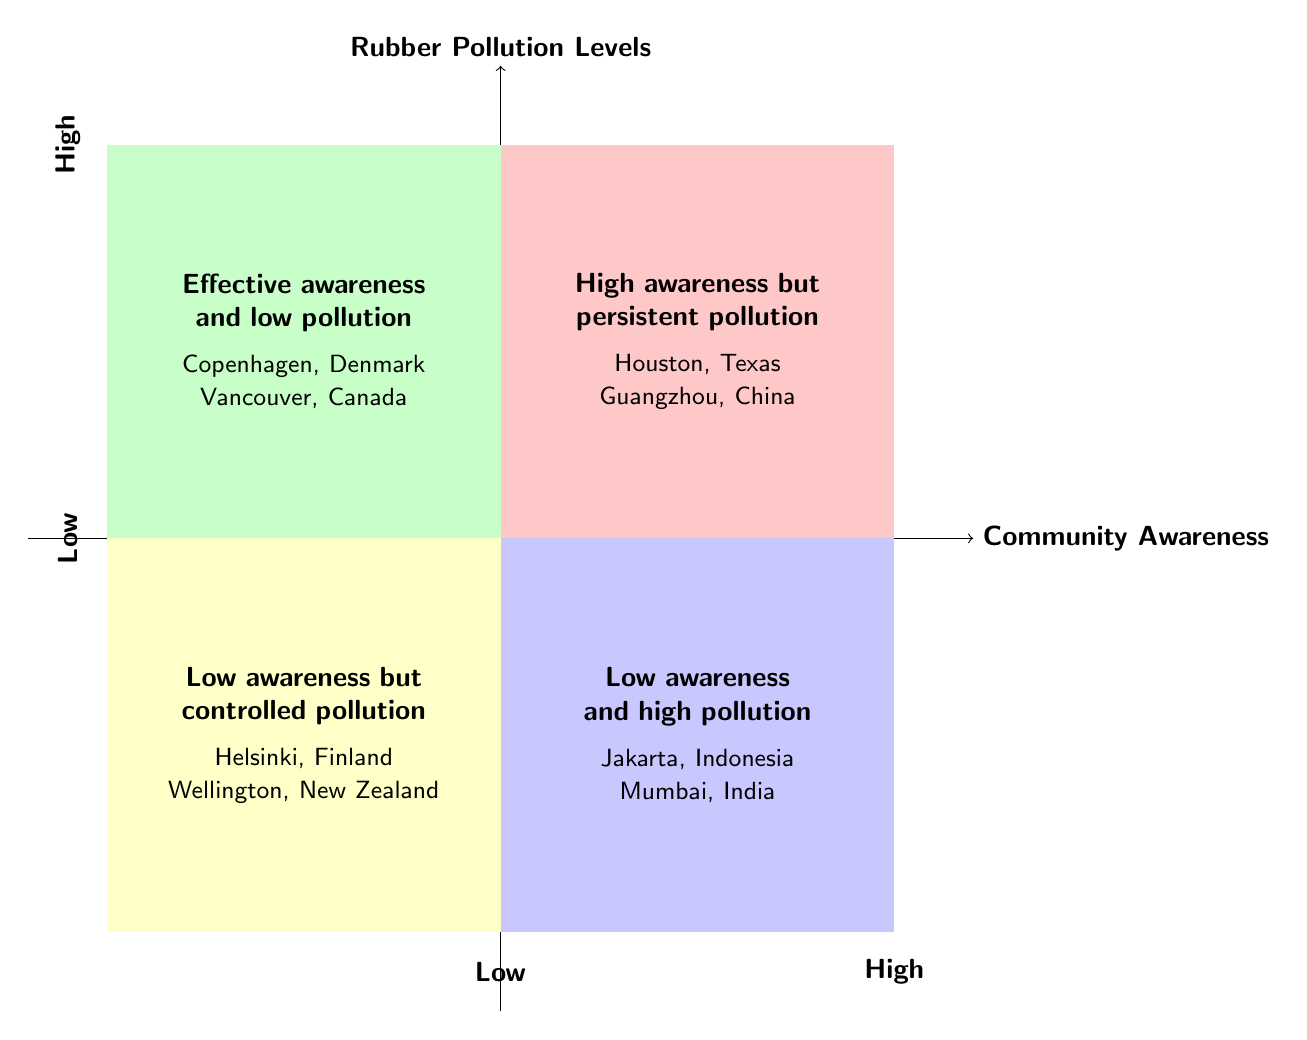What are the characteristics found in the high community awareness and high rubber pollution quadrant? The high community awareness and high rubber pollution quadrant contains characteristics such as community engagement in cleanup initiatives, high levels of rubber waste from industrial activities, and numerous public talks and awareness campaigns.
Answer: Community engagement, industrial waste, public talks Which cities are examples of low awareness and high pollution? The quadrant representing low awareness and high pollution includes examples such as Jakarta, Indonesia, and Mumbai, India.
Answer: Jakarta, Mumbai What is the pollution level in the effective awareness and low pollution quadrant? The quadrant labeled for effective awareness and low pollution implies low pollution levels, as indicated by its position on the y-axis of the diagram.
Answer: Low What quadrant has the most community engagement? The quadrant with high community awareness and high rubber pollution contains descriptions that indicate active community engagement in cleanup initiatives.
Answer: High awareness, high pollution What description fits the low awareness but controlled pollution quadrant? This quadrant is described as having minimal involvement in pollution initiatives and effective governmental regulations in place, supporting controlled pollution.
Answer: Minimal involvement, effective regulations Which cities demonstrate effective awareness and low pollution? The quadrant showcasing effective awareness and low pollution includes examples such as Copenhagen, Denmark, and Vancouver, Canada.
Answer: Copenhagen, Vancouver Which quadrant has high community awareness and low pollution? The quadrant representing high community awareness and low rubber pollution is specifically labeled for effective awareness and low pollution, highlighting its characteristics.
Answer: Effective awareness and low pollution What does the x-axis represent? The x-axis of the diagram represents Community Awareness, indicating the level of knowledge and participation within the community.
Answer: Community Awareness 